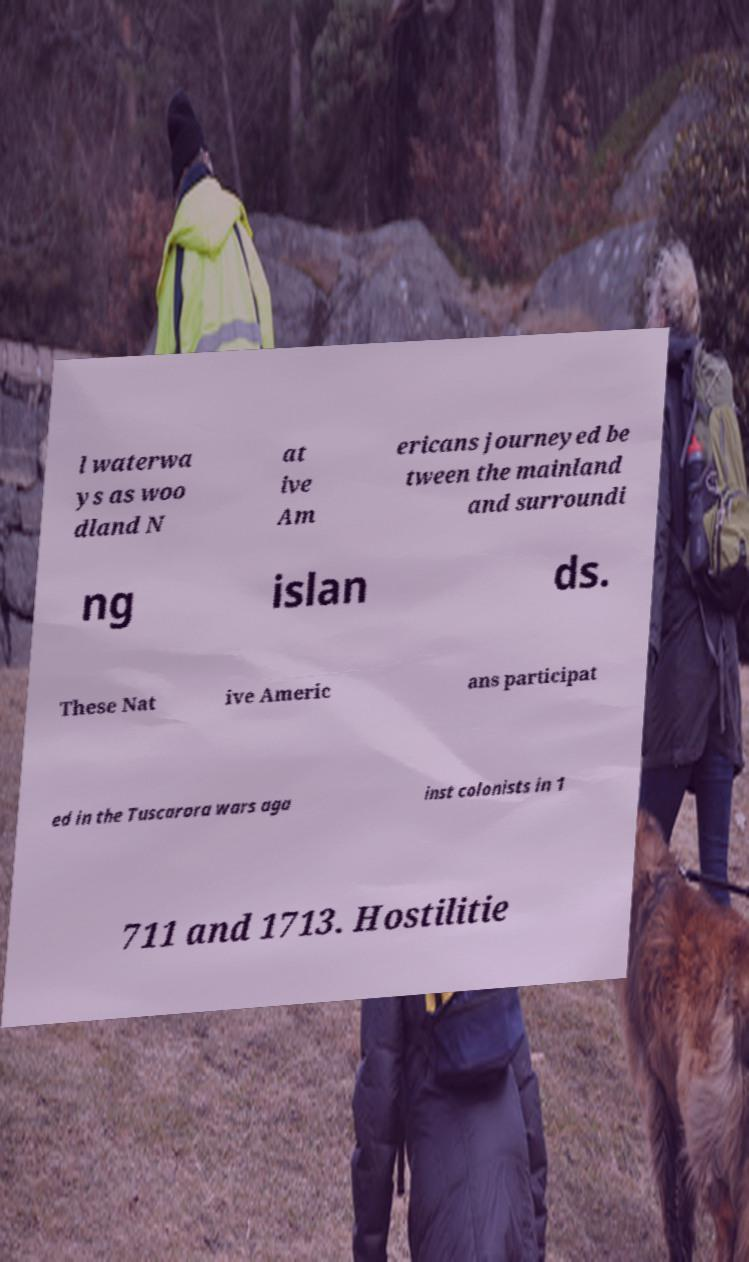Please read and relay the text visible in this image. What does it say? l waterwa ys as woo dland N at ive Am ericans journeyed be tween the mainland and surroundi ng islan ds. These Nat ive Americ ans participat ed in the Tuscarora wars aga inst colonists in 1 711 and 1713. Hostilitie 